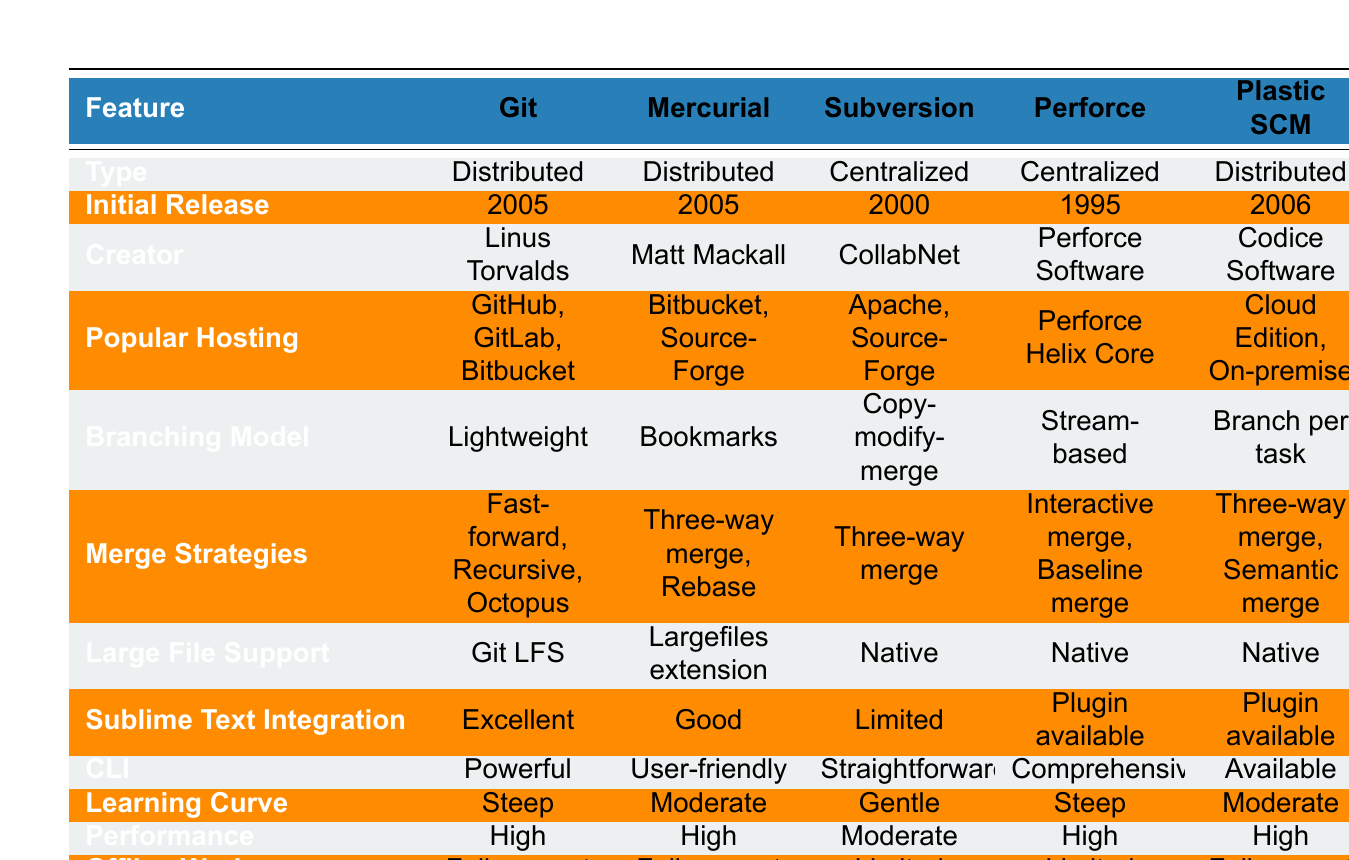What type of version control system is Git? Git is categorized as a Distributed version control system as indicated in the first row of the table.
Answer: Distributed Which version control system has a creator named Matt Mackall? The table shows that Mercurial is the version control system created by Matt Mackall in the third row under the creator column.
Answer: Mercurial Does Subversion have full support for offline work? According to the table, Subversion is noted to have limited support for offline work in the last row under the offline work column.
Answer: No What is the branching model of Plastic SCM? From the table, it is listed that Plastic SCM uses the "Branch per task" branching model in the row corresponding to this system.
Answer: Branch per task Which version control systems support native large files? By looking at the large file support column, we see that Subversion, Perforce, and Plastic SCM all mention native support for large files.
Answer: Subversion, Perforce, Plastic SCM Which version control system has a user-friendly command line interface? The table indicates that Mercurial is described as having a user-friendly command line interface, as seen in the corresponding row.
Answer: Mercurial If you were to average the performance ratings of all the version control systems, what would it be? The table lists performance ratings as High (5), Moderate (2). To calculate the average, convert High to 1 and Moderate to 0.5: (1 + 1 + 0.5 + 0.5 + 1) / 5 = 0.8. The average performance rating is closer to High.
Answer: Closer to High What version control system has limited Sublime Text integration? The table shows Subversion in the corresponding row has limited Sublime Text integration in the sixth row under the integration column.
Answer: Subversion Which version control systems were released before 2000? Reviewing the initial release dates in the second column, Perforce (1995) and Subversion (2000) were released before 2000.
Answer: Perforce, Subversion 